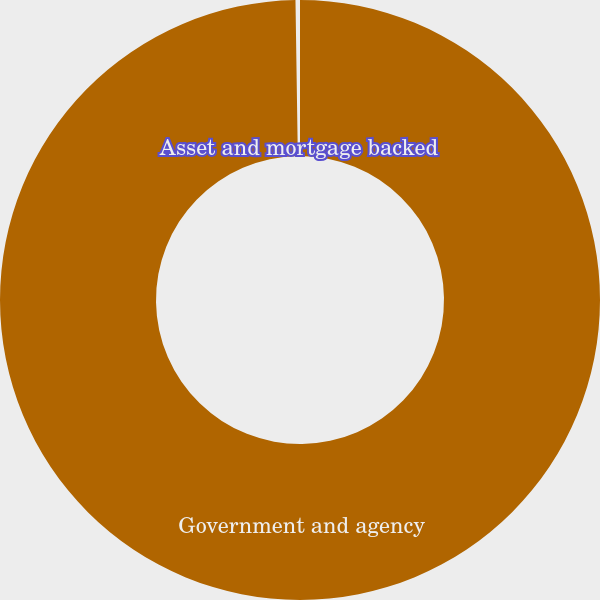Convert chart to OTSL. <chart><loc_0><loc_0><loc_500><loc_500><pie_chart><fcel>Government and agency<fcel>Asset and mortgage backed<nl><fcel>99.76%<fcel>0.24%<nl></chart> 